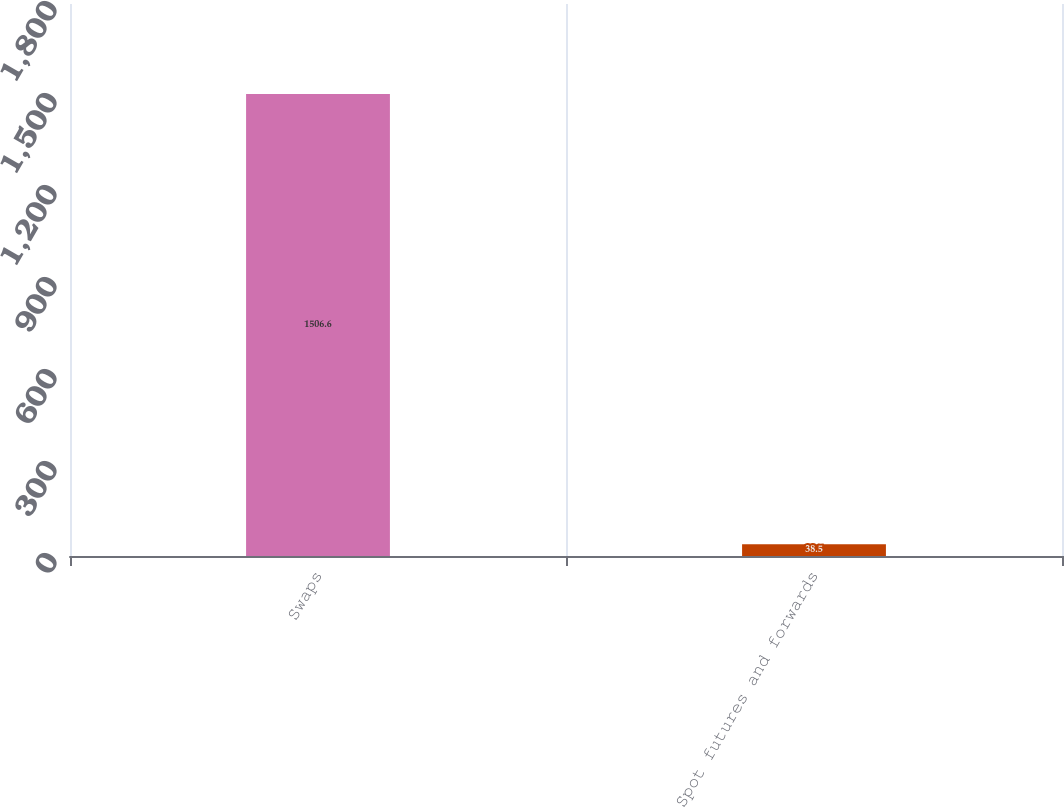Convert chart. <chart><loc_0><loc_0><loc_500><loc_500><bar_chart><fcel>Swaps<fcel>Spot futures and forwards<nl><fcel>1506.6<fcel>38.5<nl></chart> 